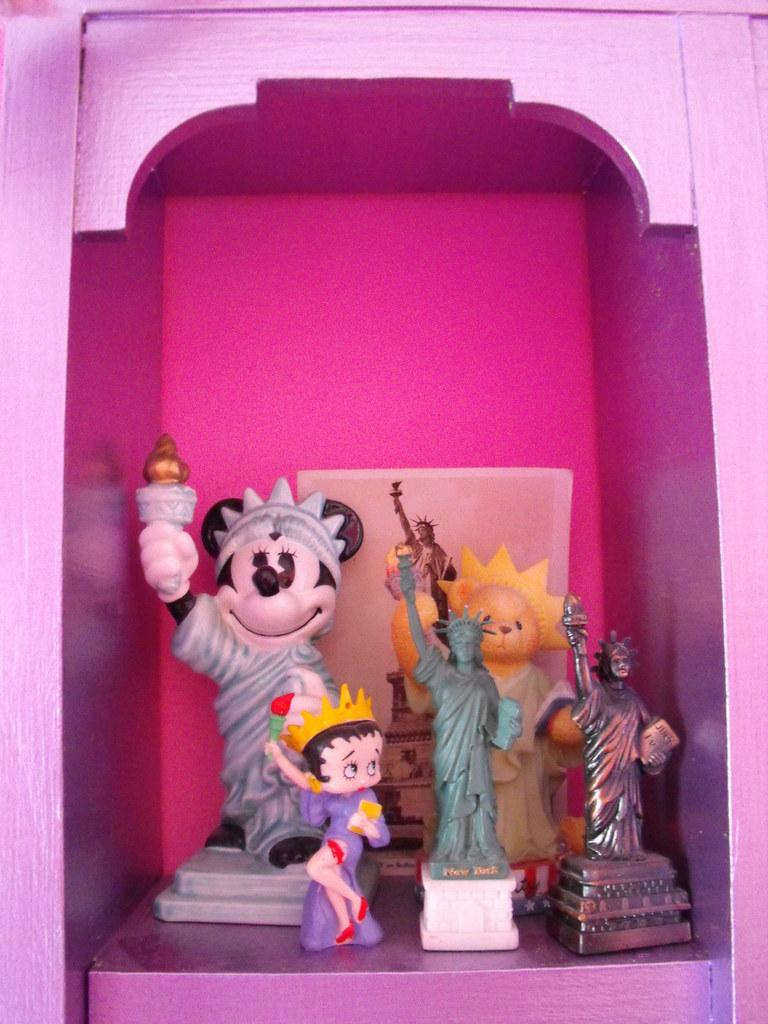What objects are present in the image? There are dolls in the image. Where are the dolls located? The dolls are present in a wooden rack. What is the name of the carriage that the dolls are riding in the image? There is no carriage present in the image; the dolls are located in a wooden rack. 